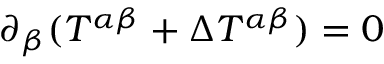Convert formula to latex. <formula><loc_0><loc_0><loc_500><loc_500>\partial _ { \beta } ( T ^ { \alpha \beta } + \Delta T ^ { \alpha \beta } ) = 0</formula> 